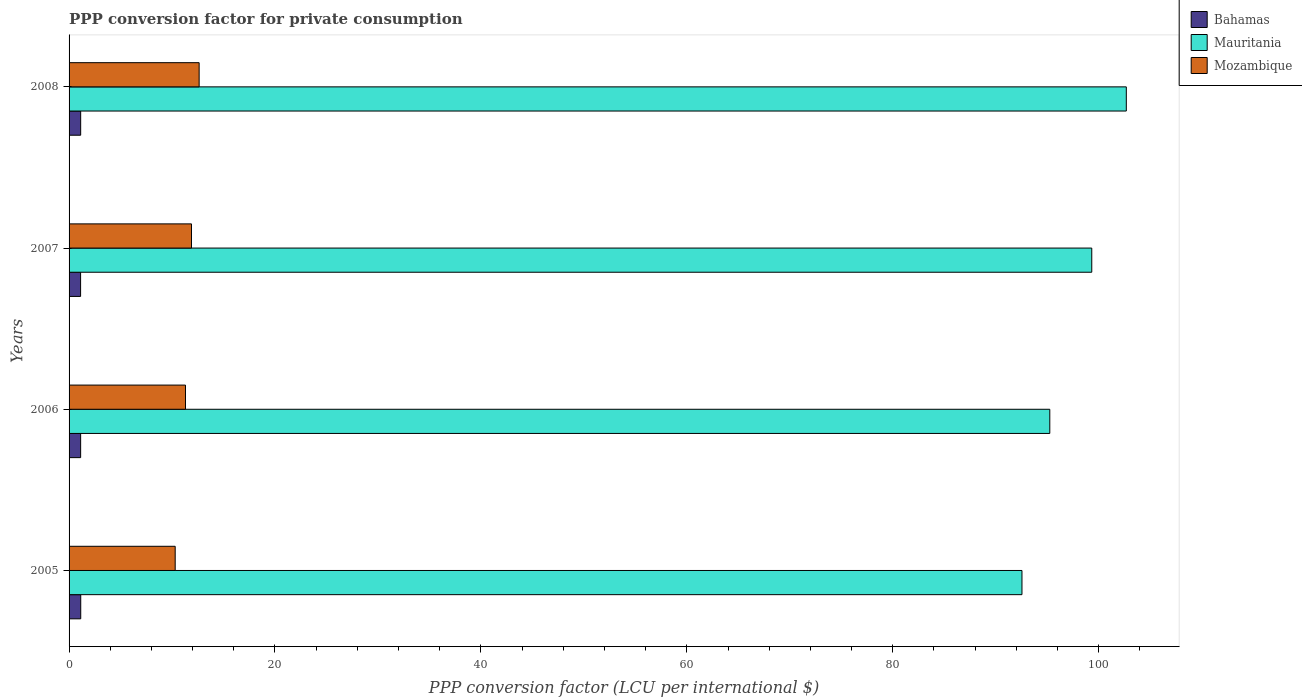How many bars are there on the 4th tick from the bottom?
Your response must be concise. 3. What is the label of the 4th group of bars from the top?
Your answer should be compact. 2005. In how many cases, is the number of bars for a given year not equal to the number of legend labels?
Provide a succinct answer. 0. What is the PPP conversion factor for private consumption in Bahamas in 2006?
Offer a very short reply. 1.12. Across all years, what is the maximum PPP conversion factor for private consumption in Mozambique?
Keep it short and to the point. 12.63. Across all years, what is the minimum PPP conversion factor for private consumption in Mauritania?
Make the answer very short. 92.55. In which year was the PPP conversion factor for private consumption in Mauritania maximum?
Ensure brevity in your answer.  2008. What is the total PPP conversion factor for private consumption in Mozambique in the graph?
Provide a succinct answer. 46.14. What is the difference between the PPP conversion factor for private consumption in Mozambique in 2007 and that in 2008?
Give a very brief answer. -0.74. What is the difference between the PPP conversion factor for private consumption in Bahamas in 2005 and the PPP conversion factor for private consumption in Mauritania in 2007?
Offer a terse response. -98.2. What is the average PPP conversion factor for private consumption in Mozambique per year?
Provide a succinct answer. 11.53. In the year 2008, what is the difference between the PPP conversion factor for private consumption in Mozambique and PPP conversion factor for private consumption in Bahamas?
Provide a short and direct response. 11.51. In how many years, is the PPP conversion factor for private consumption in Mozambique greater than 68 LCU?
Provide a succinct answer. 0. What is the ratio of the PPP conversion factor for private consumption in Mozambique in 2005 to that in 2006?
Your answer should be very brief. 0.91. Is the PPP conversion factor for private consumption in Bahamas in 2005 less than that in 2008?
Offer a very short reply. No. Is the difference between the PPP conversion factor for private consumption in Mozambique in 2005 and 2007 greater than the difference between the PPP conversion factor for private consumption in Bahamas in 2005 and 2007?
Make the answer very short. No. What is the difference between the highest and the second highest PPP conversion factor for private consumption in Mauritania?
Ensure brevity in your answer.  3.36. What is the difference between the highest and the lowest PPP conversion factor for private consumption in Bahamas?
Ensure brevity in your answer.  0.01. Is the sum of the PPP conversion factor for private consumption in Mauritania in 2005 and 2008 greater than the maximum PPP conversion factor for private consumption in Bahamas across all years?
Keep it short and to the point. Yes. What does the 2nd bar from the top in 2007 represents?
Your answer should be very brief. Mauritania. What does the 3rd bar from the bottom in 2006 represents?
Give a very brief answer. Mozambique. Is it the case that in every year, the sum of the PPP conversion factor for private consumption in Bahamas and PPP conversion factor for private consumption in Mauritania is greater than the PPP conversion factor for private consumption in Mozambique?
Your answer should be very brief. Yes. How many bars are there?
Provide a short and direct response. 12. How many years are there in the graph?
Give a very brief answer. 4. Are the values on the major ticks of X-axis written in scientific E-notation?
Make the answer very short. No. Does the graph contain any zero values?
Keep it short and to the point. No. Does the graph contain grids?
Keep it short and to the point. No. Where does the legend appear in the graph?
Your response must be concise. Top right. What is the title of the graph?
Offer a very short reply. PPP conversion factor for private consumption. Does "Mauritania" appear as one of the legend labels in the graph?
Your answer should be compact. Yes. What is the label or title of the X-axis?
Offer a very short reply. PPP conversion factor (LCU per international $). What is the PPP conversion factor (LCU per international $) of Bahamas in 2005?
Your response must be concise. 1.13. What is the PPP conversion factor (LCU per international $) in Mauritania in 2005?
Keep it short and to the point. 92.55. What is the PPP conversion factor (LCU per international $) of Mozambique in 2005?
Your answer should be compact. 10.31. What is the PPP conversion factor (LCU per international $) in Bahamas in 2006?
Make the answer very short. 1.12. What is the PPP conversion factor (LCU per international $) of Mauritania in 2006?
Your answer should be very brief. 95.25. What is the PPP conversion factor (LCU per international $) of Mozambique in 2006?
Provide a succinct answer. 11.31. What is the PPP conversion factor (LCU per international $) in Bahamas in 2007?
Provide a short and direct response. 1.12. What is the PPP conversion factor (LCU per international $) in Mauritania in 2007?
Keep it short and to the point. 99.33. What is the PPP conversion factor (LCU per international $) of Mozambique in 2007?
Keep it short and to the point. 11.89. What is the PPP conversion factor (LCU per international $) in Bahamas in 2008?
Provide a short and direct response. 1.13. What is the PPP conversion factor (LCU per international $) in Mauritania in 2008?
Give a very brief answer. 102.68. What is the PPP conversion factor (LCU per international $) of Mozambique in 2008?
Your answer should be very brief. 12.63. Across all years, what is the maximum PPP conversion factor (LCU per international $) of Bahamas?
Provide a succinct answer. 1.13. Across all years, what is the maximum PPP conversion factor (LCU per international $) of Mauritania?
Offer a terse response. 102.68. Across all years, what is the maximum PPP conversion factor (LCU per international $) of Mozambique?
Keep it short and to the point. 12.63. Across all years, what is the minimum PPP conversion factor (LCU per international $) in Bahamas?
Your answer should be very brief. 1.12. Across all years, what is the minimum PPP conversion factor (LCU per international $) of Mauritania?
Offer a terse response. 92.55. Across all years, what is the minimum PPP conversion factor (LCU per international $) of Mozambique?
Provide a short and direct response. 10.31. What is the total PPP conversion factor (LCU per international $) of Bahamas in the graph?
Give a very brief answer. 4.5. What is the total PPP conversion factor (LCU per international $) of Mauritania in the graph?
Your response must be concise. 389.82. What is the total PPP conversion factor (LCU per international $) in Mozambique in the graph?
Your answer should be compact. 46.14. What is the difference between the PPP conversion factor (LCU per international $) in Bahamas in 2005 and that in 2006?
Your answer should be very brief. 0.01. What is the difference between the PPP conversion factor (LCU per international $) of Mauritania in 2005 and that in 2006?
Your answer should be compact. -2.7. What is the difference between the PPP conversion factor (LCU per international $) in Mozambique in 2005 and that in 2006?
Ensure brevity in your answer.  -1. What is the difference between the PPP conversion factor (LCU per international $) in Bahamas in 2005 and that in 2007?
Ensure brevity in your answer.  0.01. What is the difference between the PPP conversion factor (LCU per international $) of Mauritania in 2005 and that in 2007?
Your answer should be compact. -6.78. What is the difference between the PPP conversion factor (LCU per international $) of Mozambique in 2005 and that in 2007?
Your response must be concise. -1.58. What is the difference between the PPP conversion factor (LCU per international $) in Bahamas in 2005 and that in 2008?
Keep it short and to the point. 0.01. What is the difference between the PPP conversion factor (LCU per international $) in Mauritania in 2005 and that in 2008?
Provide a succinct answer. -10.13. What is the difference between the PPP conversion factor (LCU per international $) of Mozambique in 2005 and that in 2008?
Offer a terse response. -2.33. What is the difference between the PPP conversion factor (LCU per international $) of Bahamas in 2006 and that in 2007?
Offer a very short reply. 0. What is the difference between the PPP conversion factor (LCU per international $) of Mauritania in 2006 and that in 2007?
Provide a short and direct response. -4.08. What is the difference between the PPP conversion factor (LCU per international $) in Mozambique in 2006 and that in 2007?
Your response must be concise. -0.58. What is the difference between the PPP conversion factor (LCU per international $) in Bahamas in 2006 and that in 2008?
Offer a terse response. -0. What is the difference between the PPP conversion factor (LCU per international $) in Mauritania in 2006 and that in 2008?
Keep it short and to the point. -7.43. What is the difference between the PPP conversion factor (LCU per international $) in Mozambique in 2006 and that in 2008?
Make the answer very short. -1.33. What is the difference between the PPP conversion factor (LCU per international $) of Bahamas in 2007 and that in 2008?
Keep it short and to the point. -0.01. What is the difference between the PPP conversion factor (LCU per international $) in Mauritania in 2007 and that in 2008?
Make the answer very short. -3.36. What is the difference between the PPP conversion factor (LCU per international $) of Mozambique in 2007 and that in 2008?
Offer a terse response. -0.74. What is the difference between the PPP conversion factor (LCU per international $) of Bahamas in 2005 and the PPP conversion factor (LCU per international $) of Mauritania in 2006?
Your answer should be compact. -94.12. What is the difference between the PPP conversion factor (LCU per international $) of Bahamas in 2005 and the PPP conversion factor (LCU per international $) of Mozambique in 2006?
Ensure brevity in your answer.  -10.17. What is the difference between the PPP conversion factor (LCU per international $) in Mauritania in 2005 and the PPP conversion factor (LCU per international $) in Mozambique in 2006?
Offer a very short reply. 81.24. What is the difference between the PPP conversion factor (LCU per international $) in Bahamas in 2005 and the PPP conversion factor (LCU per international $) in Mauritania in 2007?
Ensure brevity in your answer.  -98.2. What is the difference between the PPP conversion factor (LCU per international $) in Bahamas in 2005 and the PPP conversion factor (LCU per international $) in Mozambique in 2007?
Your answer should be compact. -10.76. What is the difference between the PPP conversion factor (LCU per international $) of Mauritania in 2005 and the PPP conversion factor (LCU per international $) of Mozambique in 2007?
Keep it short and to the point. 80.66. What is the difference between the PPP conversion factor (LCU per international $) in Bahamas in 2005 and the PPP conversion factor (LCU per international $) in Mauritania in 2008?
Offer a terse response. -101.55. What is the difference between the PPP conversion factor (LCU per international $) in Bahamas in 2005 and the PPP conversion factor (LCU per international $) in Mozambique in 2008?
Ensure brevity in your answer.  -11.5. What is the difference between the PPP conversion factor (LCU per international $) in Mauritania in 2005 and the PPP conversion factor (LCU per international $) in Mozambique in 2008?
Provide a short and direct response. 79.92. What is the difference between the PPP conversion factor (LCU per international $) in Bahamas in 2006 and the PPP conversion factor (LCU per international $) in Mauritania in 2007?
Make the answer very short. -98.21. What is the difference between the PPP conversion factor (LCU per international $) of Bahamas in 2006 and the PPP conversion factor (LCU per international $) of Mozambique in 2007?
Keep it short and to the point. -10.77. What is the difference between the PPP conversion factor (LCU per international $) of Mauritania in 2006 and the PPP conversion factor (LCU per international $) of Mozambique in 2007?
Your answer should be very brief. 83.36. What is the difference between the PPP conversion factor (LCU per international $) of Bahamas in 2006 and the PPP conversion factor (LCU per international $) of Mauritania in 2008?
Offer a terse response. -101.56. What is the difference between the PPP conversion factor (LCU per international $) of Bahamas in 2006 and the PPP conversion factor (LCU per international $) of Mozambique in 2008?
Offer a terse response. -11.51. What is the difference between the PPP conversion factor (LCU per international $) in Mauritania in 2006 and the PPP conversion factor (LCU per international $) in Mozambique in 2008?
Provide a succinct answer. 82.62. What is the difference between the PPP conversion factor (LCU per international $) in Bahamas in 2007 and the PPP conversion factor (LCU per international $) in Mauritania in 2008?
Offer a very short reply. -101.57. What is the difference between the PPP conversion factor (LCU per international $) of Bahamas in 2007 and the PPP conversion factor (LCU per international $) of Mozambique in 2008?
Give a very brief answer. -11.51. What is the difference between the PPP conversion factor (LCU per international $) of Mauritania in 2007 and the PPP conversion factor (LCU per international $) of Mozambique in 2008?
Provide a succinct answer. 86.7. What is the average PPP conversion factor (LCU per international $) of Bahamas per year?
Provide a short and direct response. 1.13. What is the average PPP conversion factor (LCU per international $) of Mauritania per year?
Provide a short and direct response. 97.45. What is the average PPP conversion factor (LCU per international $) in Mozambique per year?
Your response must be concise. 11.53. In the year 2005, what is the difference between the PPP conversion factor (LCU per international $) of Bahamas and PPP conversion factor (LCU per international $) of Mauritania?
Provide a succinct answer. -91.42. In the year 2005, what is the difference between the PPP conversion factor (LCU per international $) in Bahamas and PPP conversion factor (LCU per international $) in Mozambique?
Your answer should be very brief. -9.17. In the year 2005, what is the difference between the PPP conversion factor (LCU per international $) of Mauritania and PPP conversion factor (LCU per international $) of Mozambique?
Offer a terse response. 82.24. In the year 2006, what is the difference between the PPP conversion factor (LCU per international $) in Bahamas and PPP conversion factor (LCU per international $) in Mauritania?
Provide a short and direct response. -94.13. In the year 2006, what is the difference between the PPP conversion factor (LCU per international $) of Bahamas and PPP conversion factor (LCU per international $) of Mozambique?
Offer a terse response. -10.18. In the year 2006, what is the difference between the PPP conversion factor (LCU per international $) in Mauritania and PPP conversion factor (LCU per international $) in Mozambique?
Your answer should be compact. 83.95. In the year 2007, what is the difference between the PPP conversion factor (LCU per international $) in Bahamas and PPP conversion factor (LCU per international $) in Mauritania?
Make the answer very short. -98.21. In the year 2007, what is the difference between the PPP conversion factor (LCU per international $) of Bahamas and PPP conversion factor (LCU per international $) of Mozambique?
Your answer should be compact. -10.77. In the year 2007, what is the difference between the PPP conversion factor (LCU per international $) in Mauritania and PPP conversion factor (LCU per international $) in Mozambique?
Offer a terse response. 87.44. In the year 2008, what is the difference between the PPP conversion factor (LCU per international $) of Bahamas and PPP conversion factor (LCU per international $) of Mauritania?
Offer a very short reply. -101.56. In the year 2008, what is the difference between the PPP conversion factor (LCU per international $) in Bahamas and PPP conversion factor (LCU per international $) in Mozambique?
Provide a short and direct response. -11.51. In the year 2008, what is the difference between the PPP conversion factor (LCU per international $) of Mauritania and PPP conversion factor (LCU per international $) of Mozambique?
Keep it short and to the point. 90.05. What is the ratio of the PPP conversion factor (LCU per international $) in Bahamas in 2005 to that in 2006?
Make the answer very short. 1.01. What is the ratio of the PPP conversion factor (LCU per international $) in Mauritania in 2005 to that in 2006?
Ensure brevity in your answer.  0.97. What is the ratio of the PPP conversion factor (LCU per international $) of Mozambique in 2005 to that in 2006?
Your answer should be compact. 0.91. What is the ratio of the PPP conversion factor (LCU per international $) in Bahamas in 2005 to that in 2007?
Provide a short and direct response. 1.01. What is the ratio of the PPP conversion factor (LCU per international $) of Mauritania in 2005 to that in 2007?
Provide a succinct answer. 0.93. What is the ratio of the PPP conversion factor (LCU per international $) in Mozambique in 2005 to that in 2007?
Offer a very short reply. 0.87. What is the ratio of the PPP conversion factor (LCU per international $) in Bahamas in 2005 to that in 2008?
Your response must be concise. 1.01. What is the ratio of the PPP conversion factor (LCU per international $) of Mauritania in 2005 to that in 2008?
Your answer should be compact. 0.9. What is the ratio of the PPP conversion factor (LCU per international $) in Mozambique in 2005 to that in 2008?
Offer a terse response. 0.82. What is the ratio of the PPP conversion factor (LCU per international $) in Bahamas in 2006 to that in 2007?
Give a very brief answer. 1. What is the ratio of the PPP conversion factor (LCU per international $) of Mauritania in 2006 to that in 2007?
Ensure brevity in your answer.  0.96. What is the ratio of the PPP conversion factor (LCU per international $) of Mozambique in 2006 to that in 2007?
Provide a short and direct response. 0.95. What is the ratio of the PPP conversion factor (LCU per international $) in Bahamas in 2006 to that in 2008?
Make the answer very short. 1. What is the ratio of the PPP conversion factor (LCU per international $) in Mauritania in 2006 to that in 2008?
Your answer should be very brief. 0.93. What is the ratio of the PPP conversion factor (LCU per international $) of Mozambique in 2006 to that in 2008?
Your answer should be compact. 0.9. What is the ratio of the PPP conversion factor (LCU per international $) in Mauritania in 2007 to that in 2008?
Provide a succinct answer. 0.97. What is the ratio of the PPP conversion factor (LCU per international $) in Mozambique in 2007 to that in 2008?
Keep it short and to the point. 0.94. What is the difference between the highest and the second highest PPP conversion factor (LCU per international $) of Bahamas?
Your answer should be compact. 0.01. What is the difference between the highest and the second highest PPP conversion factor (LCU per international $) in Mauritania?
Give a very brief answer. 3.36. What is the difference between the highest and the second highest PPP conversion factor (LCU per international $) in Mozambique?
Keep it short and to the point. 0.74. What is the difference between the highest and the lowest PPP conversion factor (LCU per international $) in Bahamas?
Provide a short and direct response. 0.01. What is the difference between the highest and the lowest PPP conversion factor (LCU per international $) in Mauritania?
Make the answer very short. 10.13. What is the difference between the highest and the lowest PPP conversion factor (LCU per international $) of Mozambique?
Your response must be concise. 2.33. 